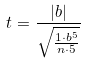Convert formula to latex. <formula><loc_0><loc_0><loc_500><loc_500>t = \frac { | b | } { \sqrt { \frac { 1 \cdot b ^ { 5 } } { n \cdot 5 } } }</formula> 